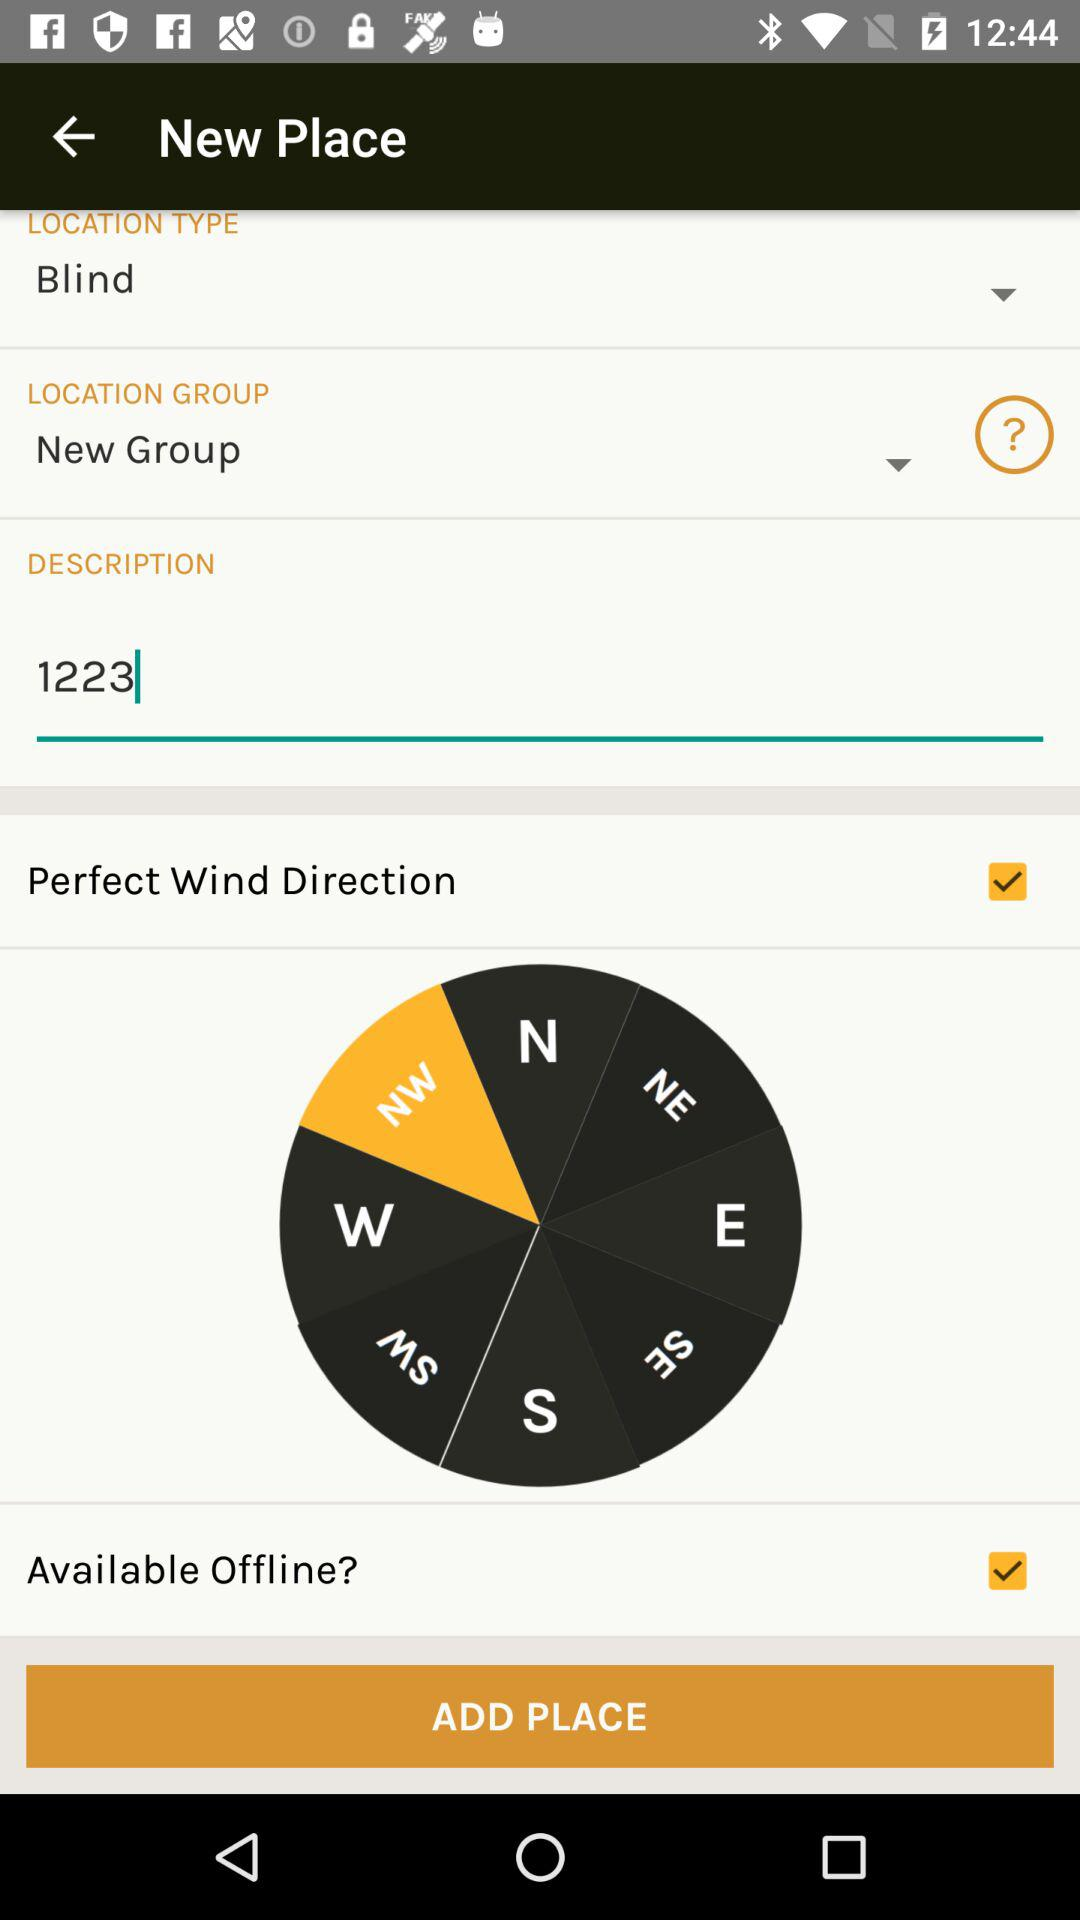What option is selected in the "LOCATION GROUP"? The selected option in "LOCATION GROUP" is "New Group". 